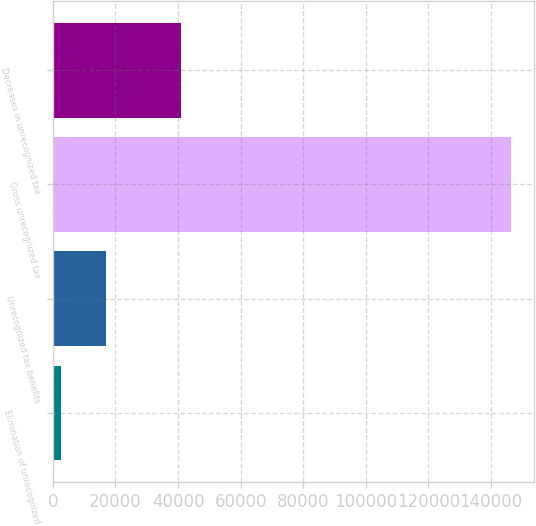Convert chart. <chart><loc_0><loc_0><loc_500><loc_500><bar_chart><fcel>Elimination of unrecognized<fcel>Unrecognized tax benefits<fcel>Gross unrecognized tax<fcel>Decreases in unrecognized tax<nl><fcel>2519<fcel>16908.3<fcel>146412<fcel>40879<nl></chart> 